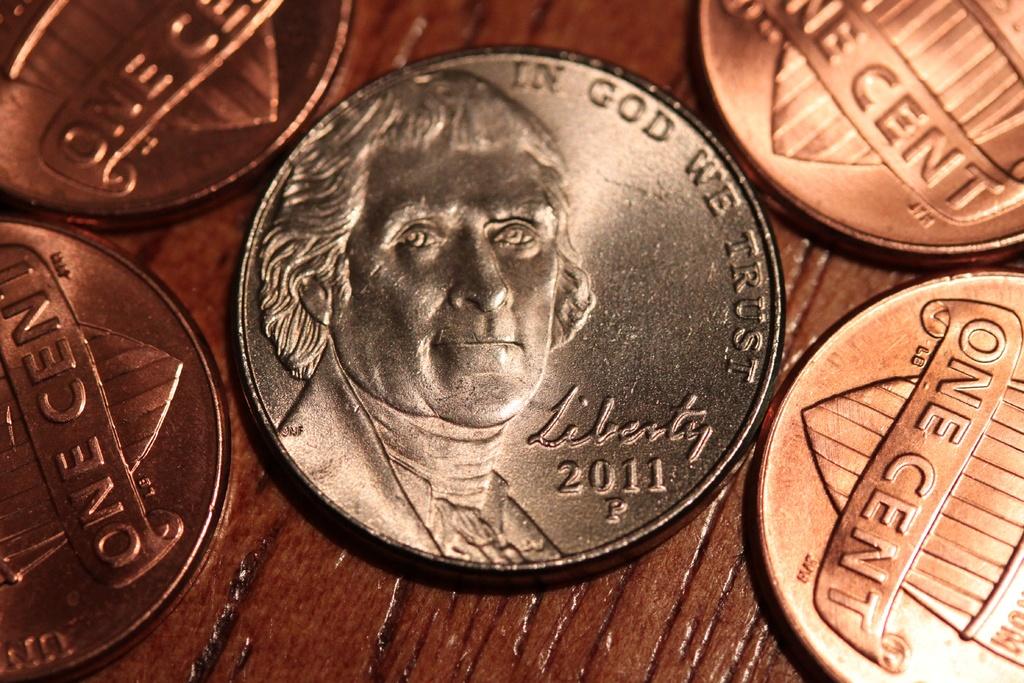When was this coin made?
Your response must be concise. 2011. This is kains?
Keep it short and to the point. Unanswerable. 